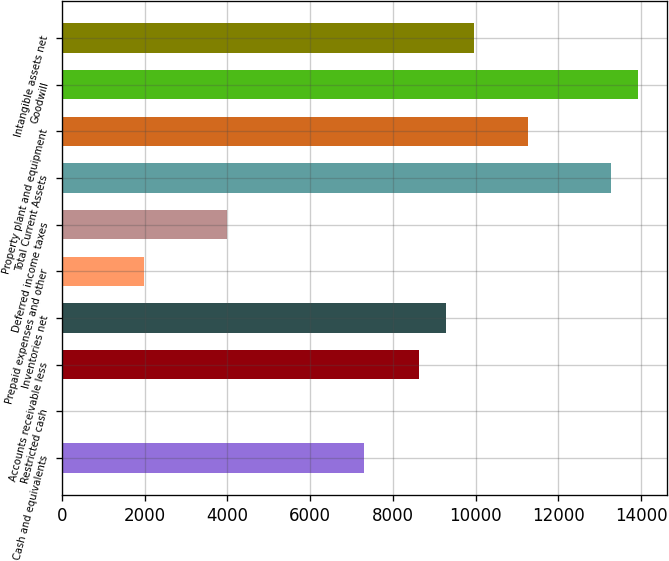Convert chart to OTSL. <chart><loc_0><loc_0><loc_500><loc_500><bar_chart><fcel>Cash and equivalents<fcel>Restricted cash<fcel>Accounts receivable less<fcel>Inventories net<fcel>Prepaid expenses and other<fcel>Deferred income taxes<fcel>Total Current Assets<fcel>Property plant and equipment<fcel>Goodwill<fcel>Intangible assets net<nl><fcel>7296.82<fcel>2.5<fcel>8623.06<fcel>9286.18<fcel>1991.86<fcel>3981.22<fcel>13264.9<fcel>11275.5<fcel>13928<fcel>9949.3<nl></chart> 